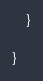Convert code to text. <code><loc_0><loc_0><loc_500><loc_500><_Java_>    }

}
</code> 